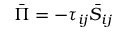<formula> <loc_0><loc_0><loc_500><loc_500>\bar { \Pi } = - { \tau _ { i j } } { { \bar { S } } _ { i j } }</formula> 